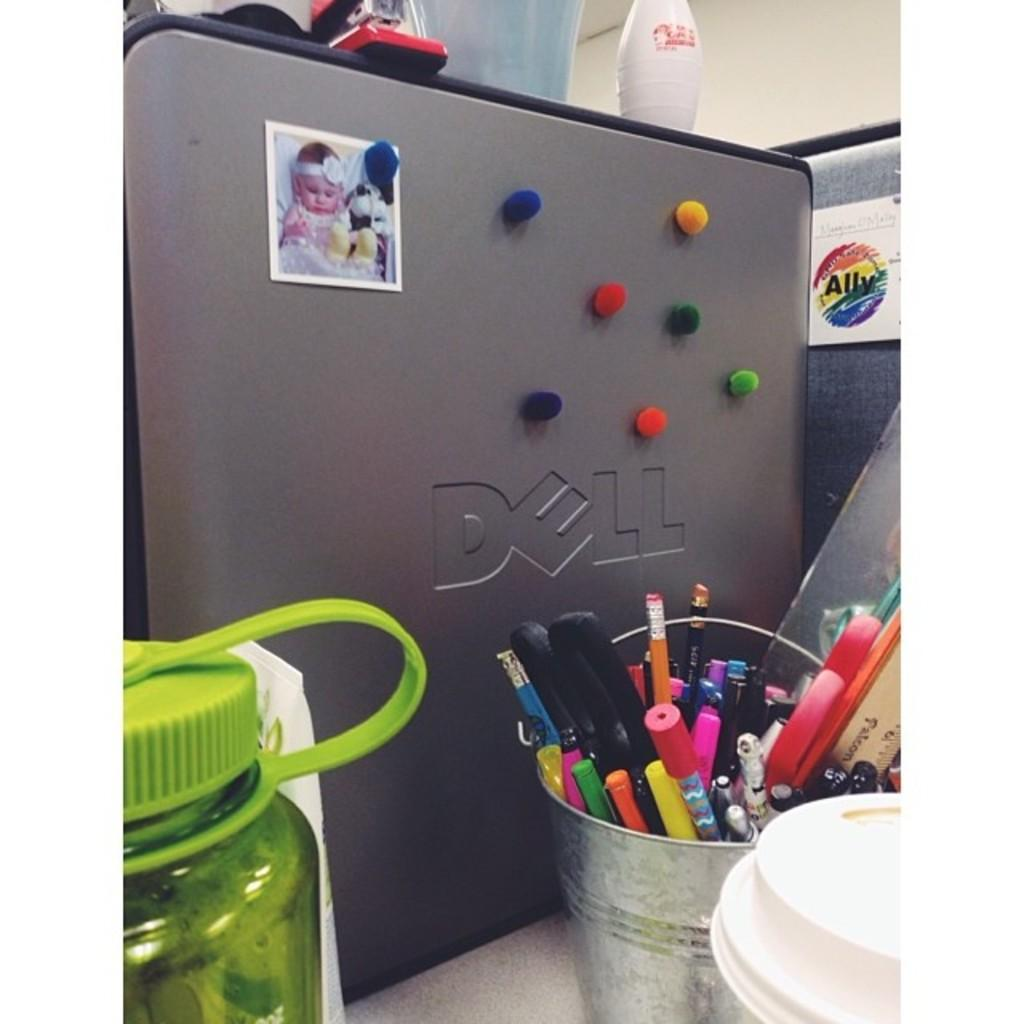<image>
Create a compact narrative representing the image presented. Several small, colorful cotton balls are on the back of a Dell computer, on an office desk. 